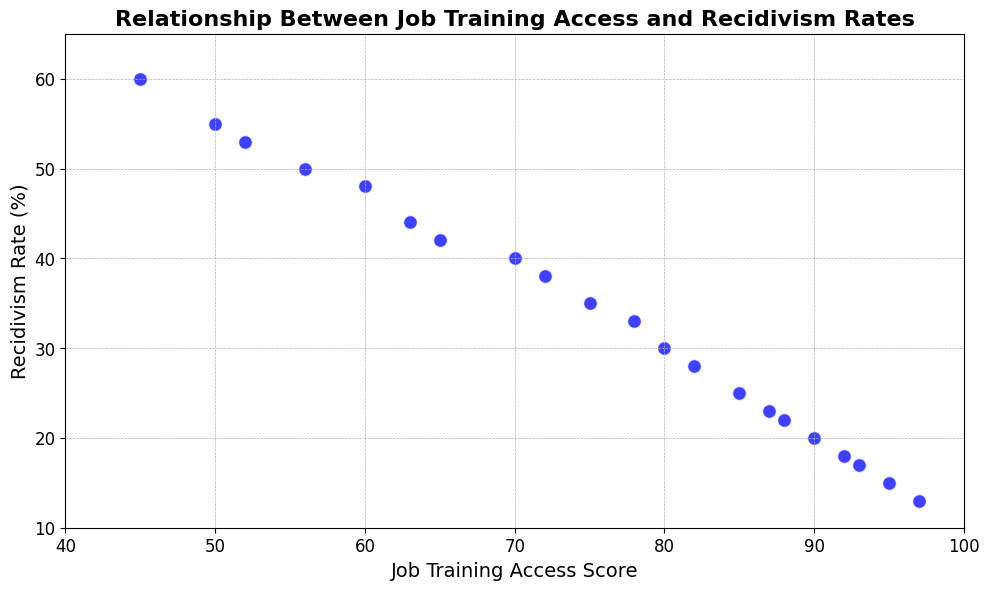What is the general trend between Job Training Access Score and Recidivism Rate? The scatter plot shows that as the Job Training Access Score increases, the Recidivism Rate generally decreases. This suggests a negative correlation between the two variables where better access to job training is associated with lower recidivism rates.
Answer: Negative correlation Compare the Job Training Access Score and Recidivism Rate for the years 2005 and 2015. In 2005, the Job Training Access Score is 63, and the Recidivism Rate is 44%. In 2015, the Job Training Access Score is 88, and the Recidivism Rate is 22%.
Answer: 2005: 63 and 44%; 2015: 88 and 22% What is the average Recidivism Rate for the years 2000 to 2010? Sum the Recidivism Rates from 2000 to 2010 and divide by the number of years. The rates are 60, 55, 53, 50, 48, 44, 42, 40, 38, 35, and 33 respectively. (60+55+53+50+48+44+42+40+38+35+33) / 11 = 44.5.
Answer: 44.5% How much does the Recidivism Rate decrease from 2000 to 2020? In 2000, the Recidivism Rate is 60%. In 2020, it is 13%. The difference is 60% - 13% = 47%.
Answer: 47% In which year did the Recidivism Rate drop below 30%? By examining the trend, it can be observed that the Recidivism Rate drops below 30% in 2011.
Answer: 2011 Is there any year where the Recidivism Rate is equal to or less than 20%? The scatter plot shows that the Recidivism Rate in 2016 is 20%, and it is less than 20% in subsequent years such as 2017, 2018, 2019, and 2020.
Answer: Yes, from 2016 onwards What is the difference in Job Training Access Score between 2000 and 2020? In 2000, the Job Training Access Score is 45. In 2020, it is 97. The difference is 97 - 45 = 52.
Answer: 52 At which Job Training Access Score is the Recidivism Rate 18%? By locating the Job Training Access Score corresponding to a Recidivism Rate of 18% on the scatter plot, it is found to be at a score of 92.
Answer: 92 What is the percent decrease in Recidivism Rate from 2009 to 2012? The Recidivism Rate in 2009 is 35%. In 2012, it is 28%. The percent decrease is ((35 - 28) / 35) * 100 = 20%.
Answer: 20% How does the range of Recidivism Rates change as Job Training Access Scores increase from 45 to 97? In the scatter plot, Recidivism Rates start high at 60% when the Job Training Access Score is 45, and decrease to 13% when the Job Training Access Score reaches 97. The range of Recidivism Rates decreases as Job Training Access Scores increase.
Answer: Decreases 